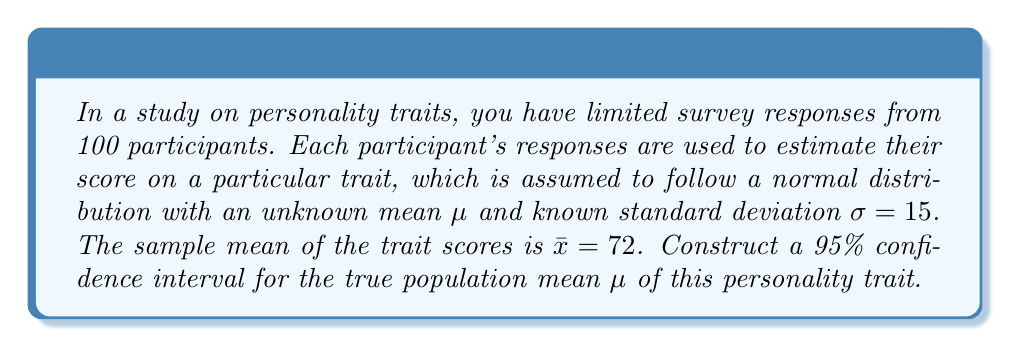Could you help me with this problem? To construct a confidence interval for the population mean $\mu$ with a known standard deviation, we'll follow these steps:

1) The formula for a confidence interval is:

   $$\bar{x} \pm z_{\alpha/2} \cdot \frac{\sigma}{\sqrt{n}}$$

   where $\bar{x}$ is the sample mean, $z_{\alpha/2}$ is the critical value from the standard normal distribution, $\sigma$ is the population standard deviation, and $n$ is the sample size.

2) We're given:
   - $\bar{x} = 72$
   - $\sigma = 15$
   - $n = 100$
   - Confidence level = 95%

3) For a 95% confidence interval, $\alpha = 0.05$, and $z_{\alpha/2} = z_{0.025} = 1.96$

4) Plugging these values into the formula:

   $$72 \pm 1.96 \cdot \frac{15}{\sqrt{100}}$$

5) Simplify:
   $$72 \pm 1.96 \cdot \frac{15}{10} = 72 \pm 1.96 \cdot 1.5 = 72 \pm 2.94$$

6) Therefore, the confidence interval is:

   $$(72 - 2.94, 72 + 2.94) = (69.06, 74.94)$$
Answer: (69.06, 74.94) 